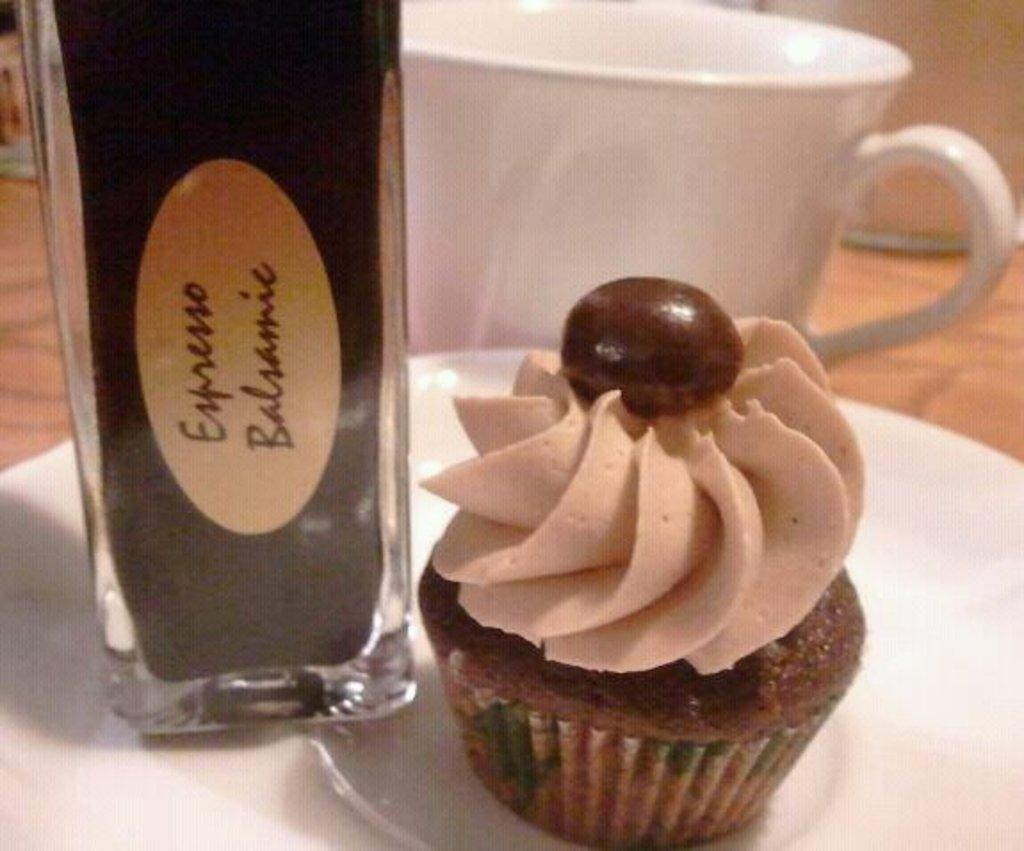<image>
Present a compact description of the photo's key features. Brown cupcake next to a brown bottle with the word expresso on it. 